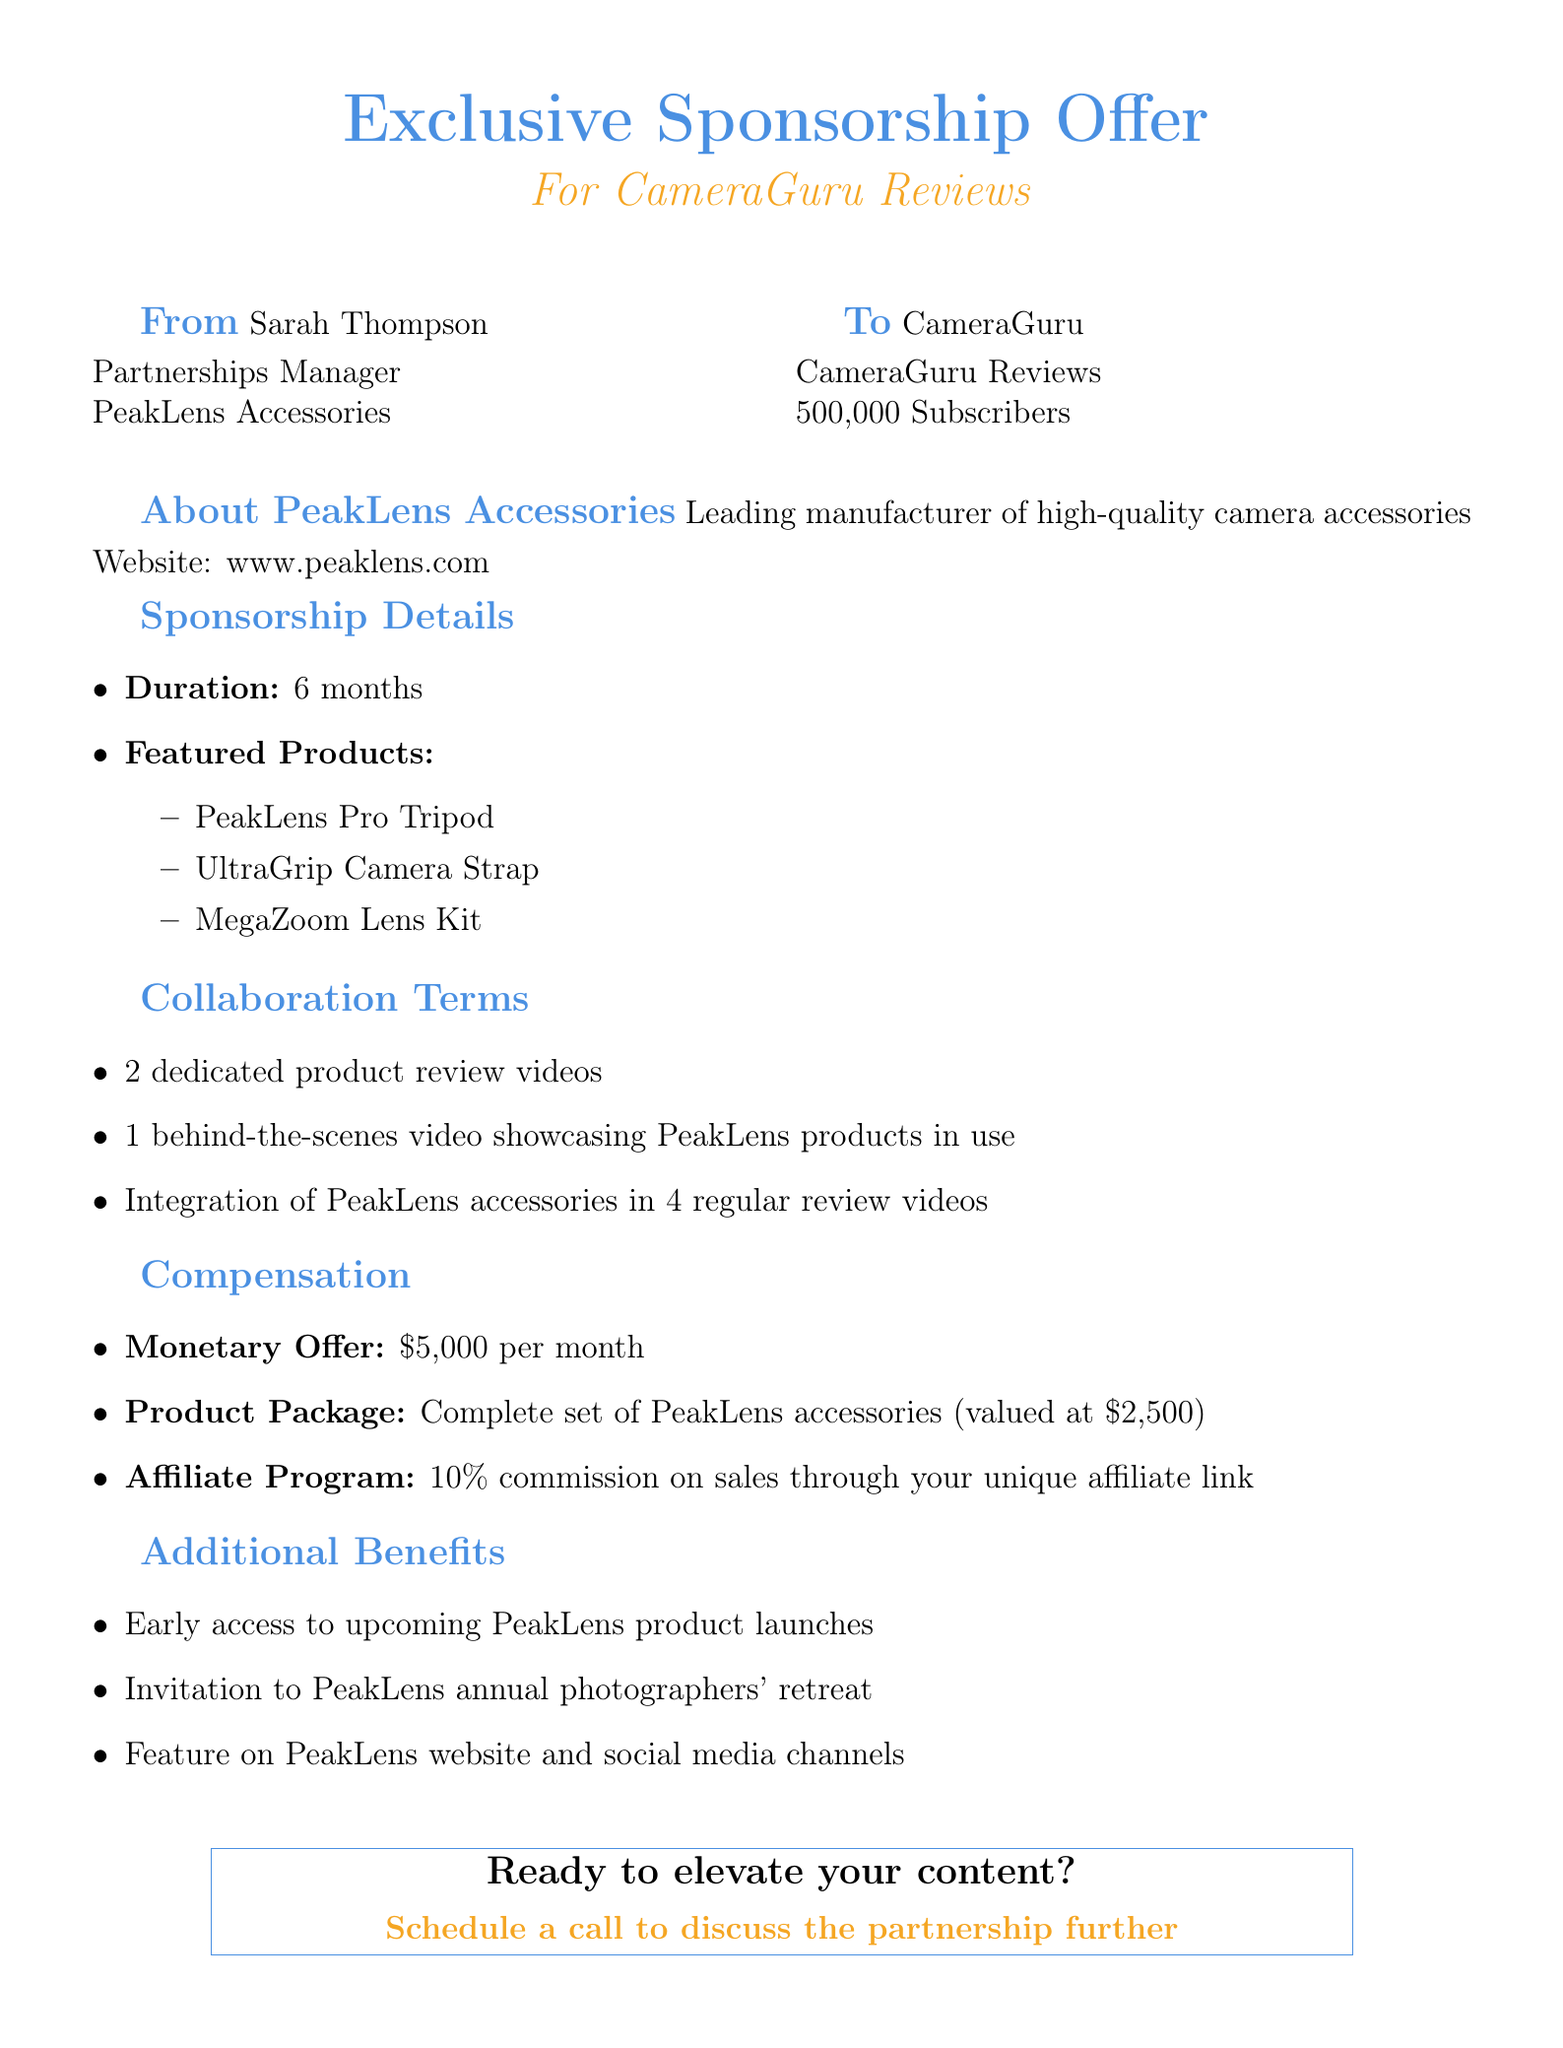What is the name of the sender? The sender of the email is Sarah Thompson.
Answer: Sarah Thompson What is the duration of the sponsorship? The email specifies that the sponsorship duration is 6 months.
Answer: 6 months How many subscribers does CameraGuru Reviews have? The document indicates that CameraGuru Reviews has 500,000 subscribers.
Answer: 500,000 What is the monthly monetary offer? The compensation section states the monetary offer is $5,000 per month.
Answer: $5,000 What product package is included in the compensation? The document mentions a complete set of PeakLens accessories valued at $2,500.
Answer: Complete set of PeakLens accessories (valued at $2,500) How many dedicated product review videos are required? The collaboration terms include 2 dedicated product review videos.
Answer: 2 What commission percentage is offered through the affiliate program? The email states a 10% commission on sales via the unique affiliate link.
Answer: 10% What is one of the additional benefits mentioned? One of the additional benefits is early access to upcoming PeakLens product launches.
Answer: Early access to upcoming PeakLens product launches What is the call to action in the email? The call to action suggests scheduling a call to discuss the partnership further.
Answer: Schedule a call to discuss the partnership further 